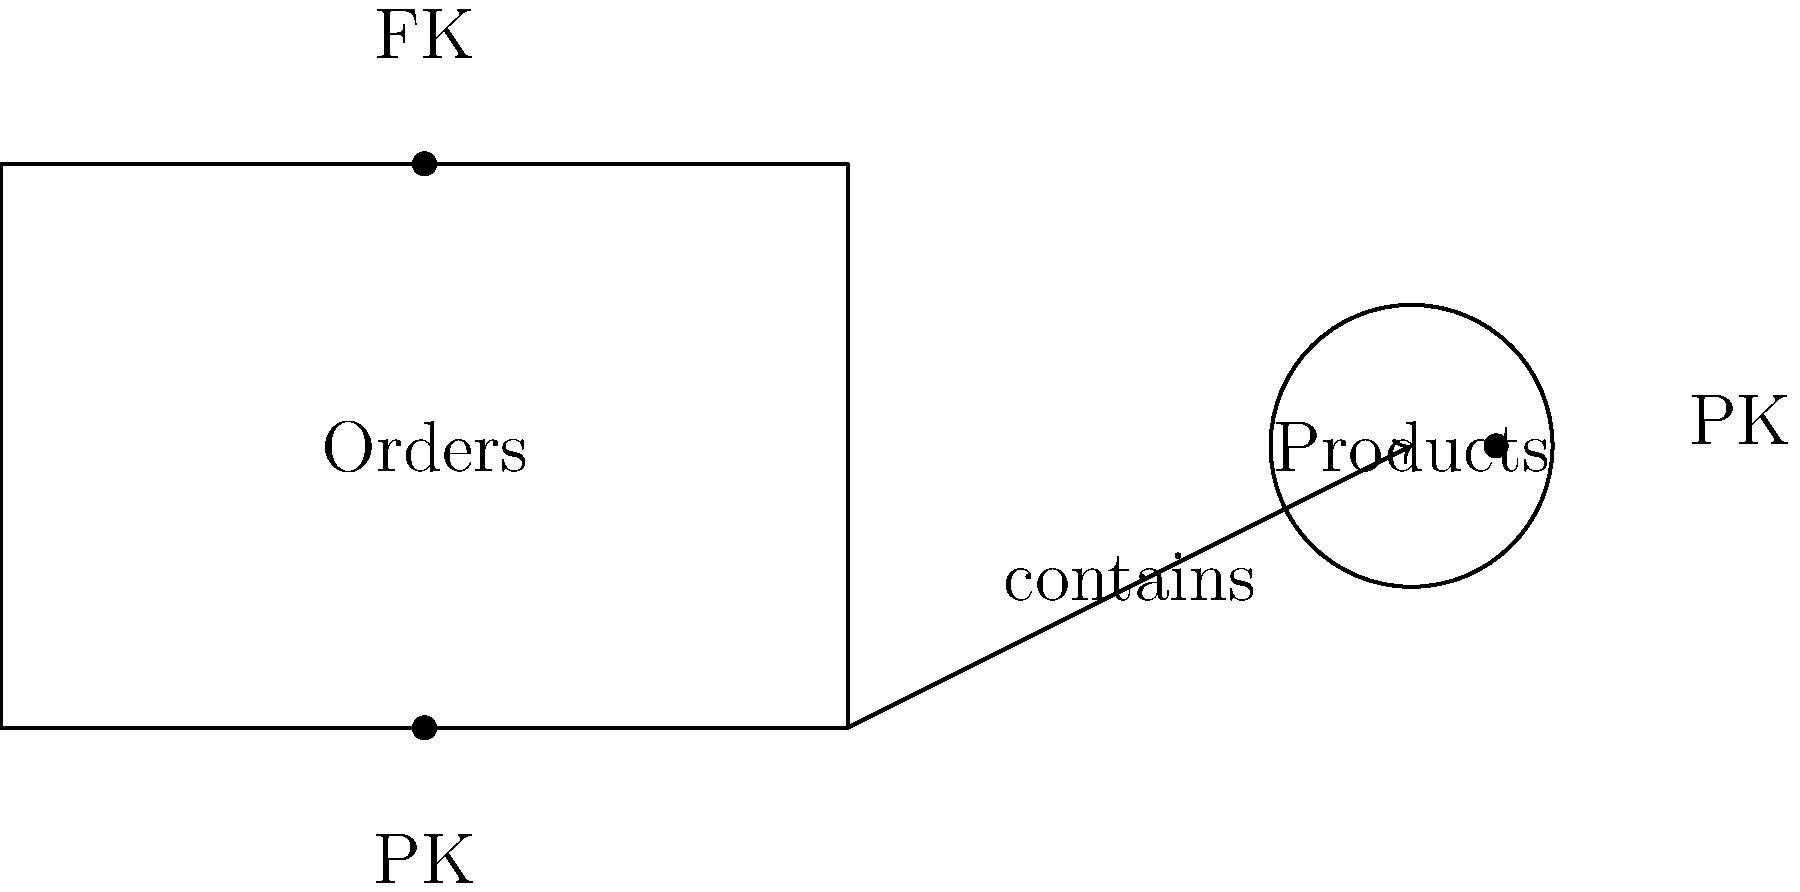Based on the entity-relationship diagram provided, which optimization technique would you recommend to improve the performance of queries involving both Orders and Products in our Java application? To optimize the database schema for improved query performance, we should consider the following steps:

1. Analyze the relationship: The diagram shows a one-to-many relationship between Orders and Products, indicated by the arrow pointing from Orders to Products.

2. Identify the keys: We can see that Orders has a Primary Key (PK) and a Foreign Key (FK), while Products has only a Primary Key (PK).

3. Consider query patterns: In a typical e-commerce scenario, we often need to retrieve product information along with order details.

4. Evaluate indexing: The Foreign Key in the Orders table is likely referencing the Primary Key of the Products table. Indexing this Foreign Key can significantly improve join performance.

5. Denormalization potential: For frequently accessed product information, we could consider adding some product details directly to the Orders table to reduce joins.

6. Caching strategy: Implement caching for frequently accessed product data to reduce database load.

Given these considerations, the most effective optimization technique would be to create an index on the Foreign Key in the Orders table that references the Products table. This index will dramatically improve the performance of join operations between Orders and Products, which are likely to be common in an e-commerce application.
Answer: Create an index on the Foreign Key in the Orders table referencing Products. 